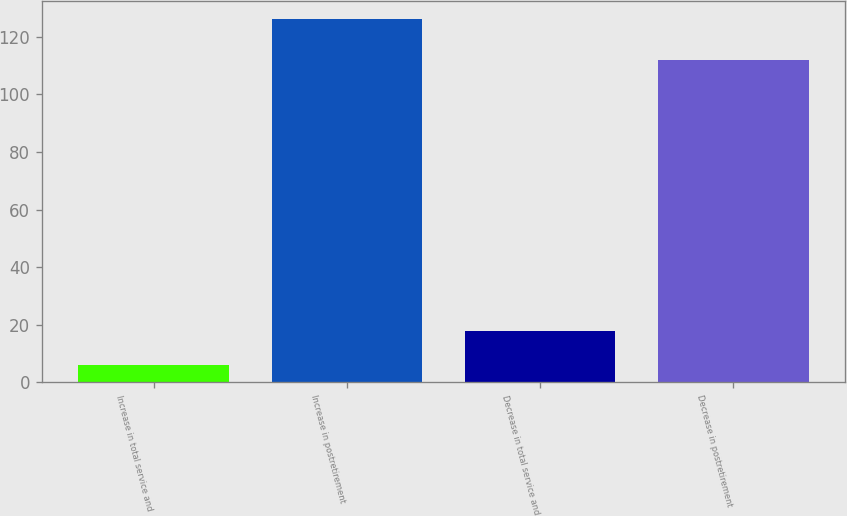Convert chart to OTSL. <chart><loc_0><loc_0><loc_500><loc_500><bar_chart><fcel>Increase in total service and<fcel>Increase in postretirement<fcel>Decrease in total service and<fcel>Decrease in postretirement<nl><fcel>6<fcel>126<fcel>18<fcel>112<nl></chart> 